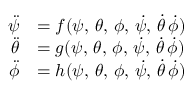Convert formula to latex. <formula><loc_0><loc_0><loc_500><loc_500>\begin{array} { r l } { \ddot { \psi } } & { = f ( \psi , \, \theta , \, \phi , \, \dot { \psi } , \, \dot { \theta } \, \dot { \phi } ) } \\ { \ddot { \theta } } & { = g ( \psi , \, \theta , \, \phi , \, \dot { \psi } , \, \dot { \theta } \, \dot { \phi } ) } \\ { \ddot { \phi } } & { = h ( \psi , \, \theta , \, \phi , \, \dot { \psi } , \, \dot { \theta } \, \dot { \phi } ) } \end{array}</formula> 